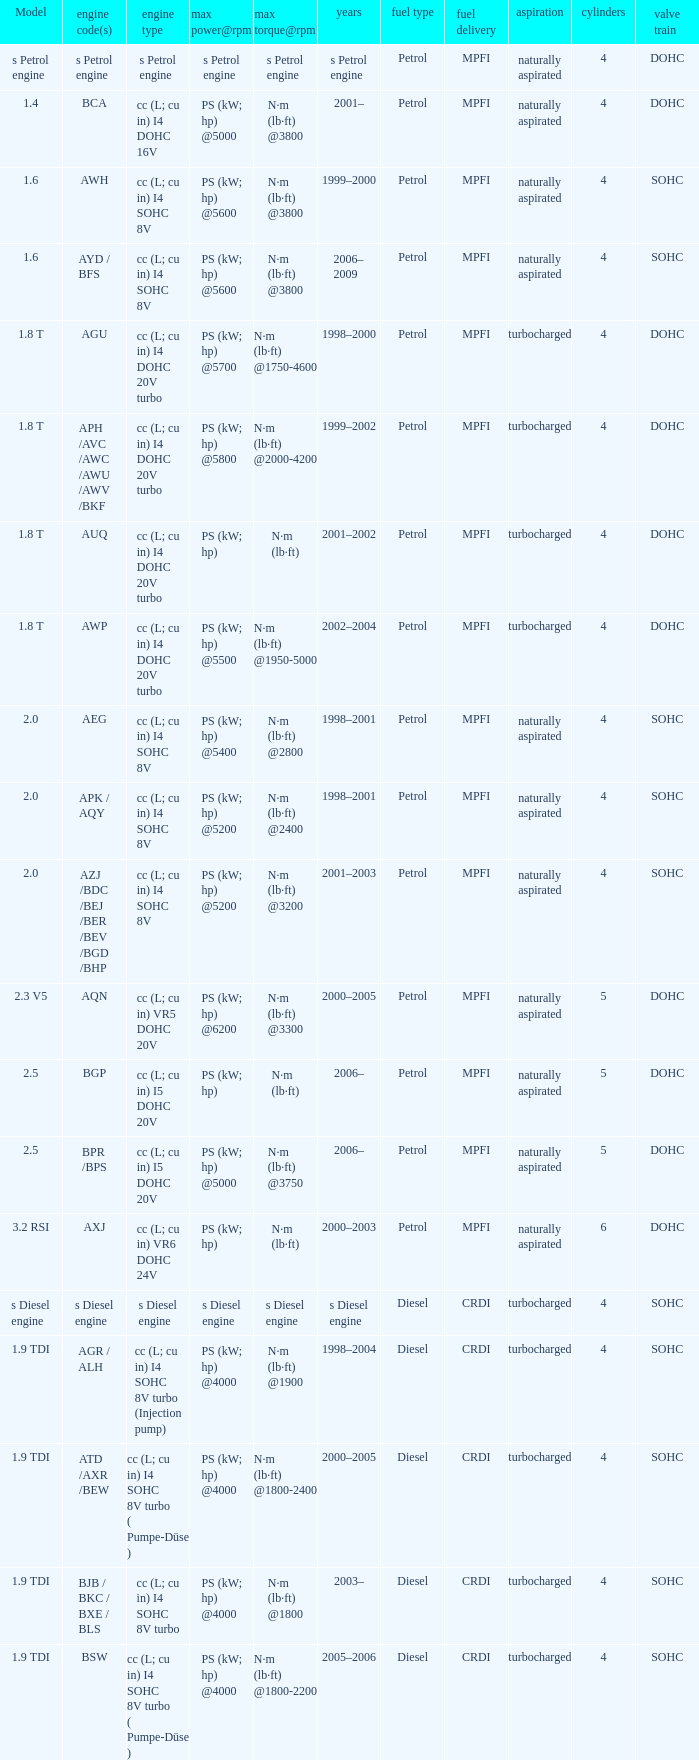Which engine type was used in the model 2.3 v5? Cc (l; cu in) vr5 dohc 20v. 